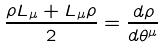<formula> <loc_0><loc_0><loc_500><loc_500>\frac { \rho L _ { \mu } + L _ { \mu } \rho } { 2 } = \frac { d \rho } { d \theta ^ { \mu } }</formula> 